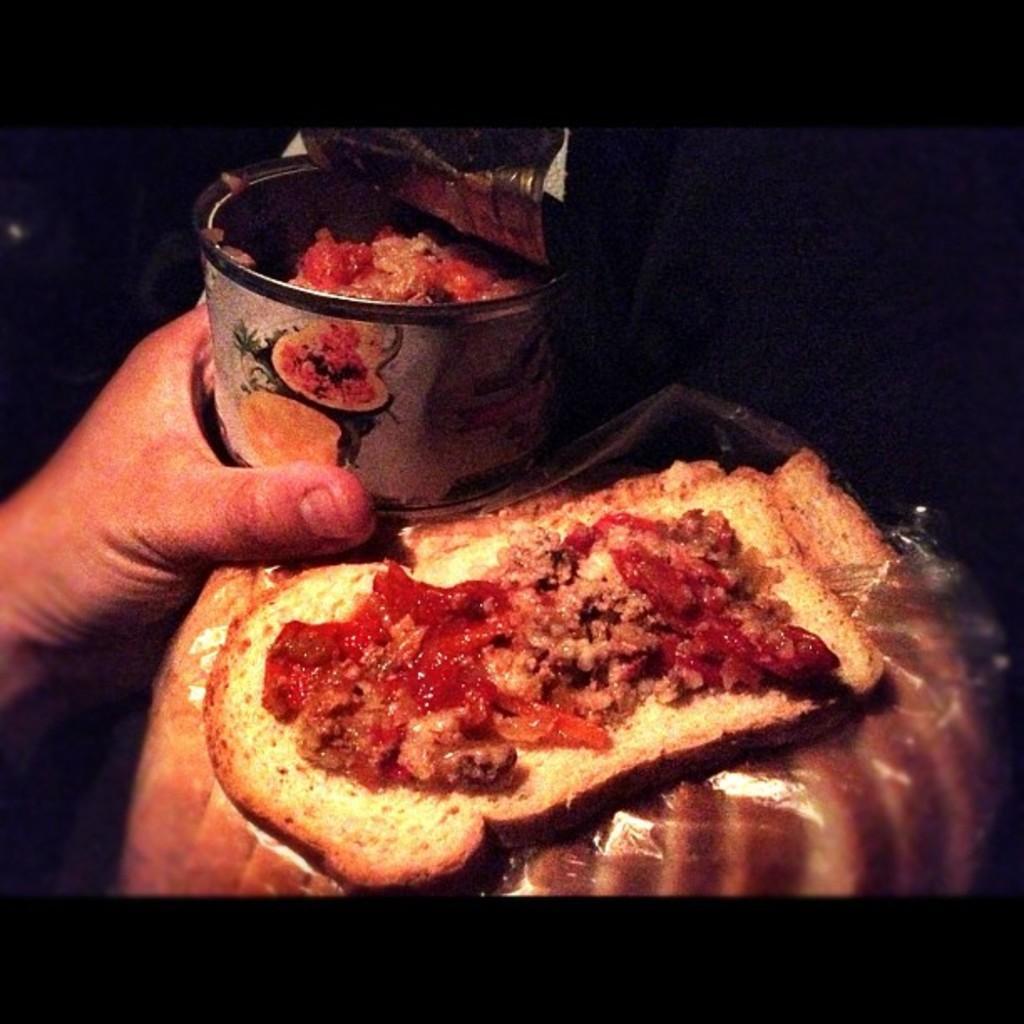How would you summarize this image in a sentence or two? In this picture we can see a person hand holding a jar, food items and in the background it is dark. 